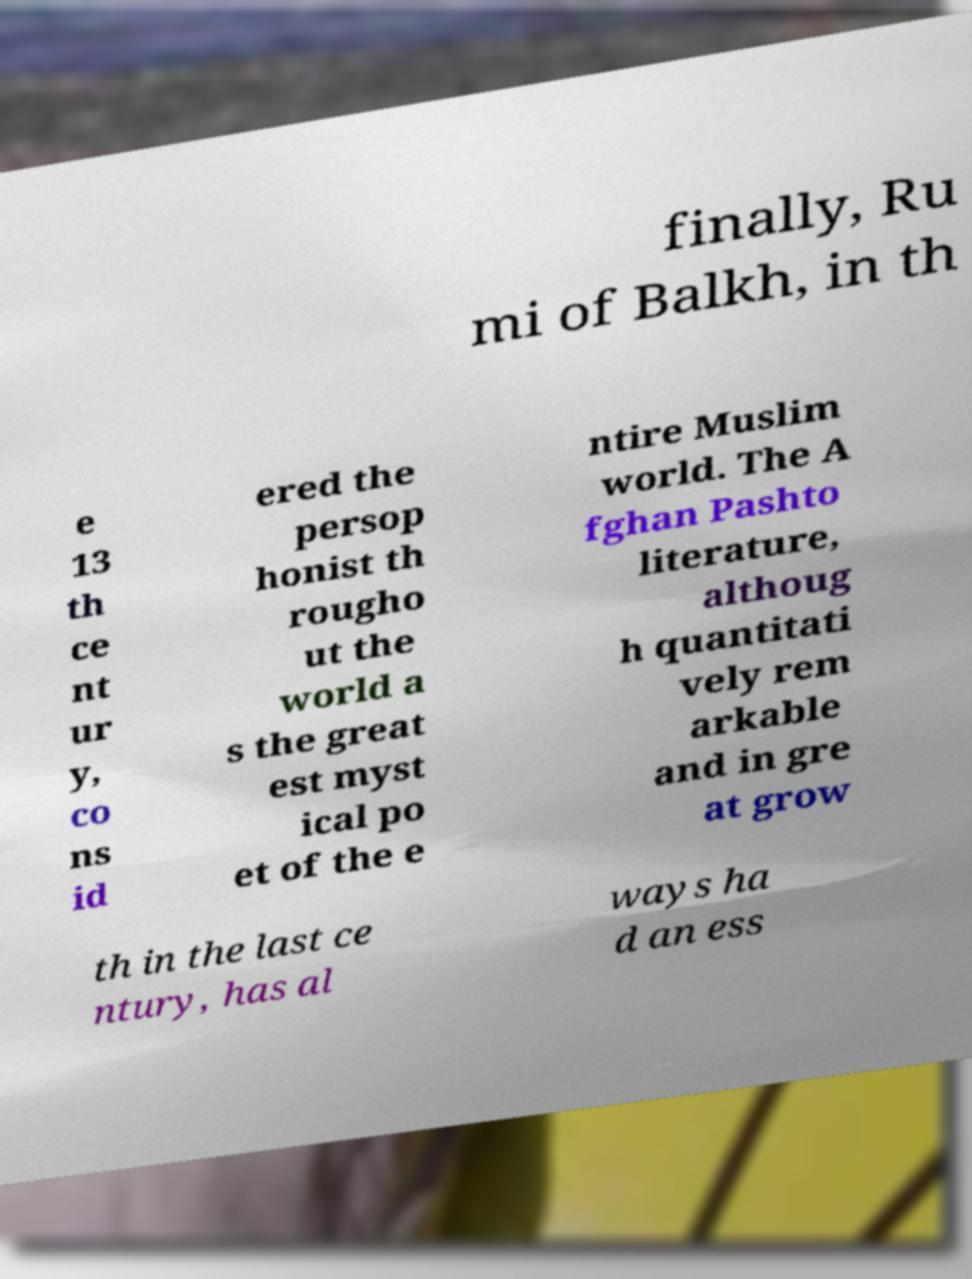Can you read and provide the text displayed in the image?This photo seems to have some interesting text. Can you extract and type it out for me? finally, Ru mi of Balkh, in th e 13 th ce nt ur y, co ns id ered the persop honist th rougho ut the world a s the great est myst ical po et of the e ntire Muslim world. The A fghan Pashto literature, althoug h quantitati vely rem arkable and in gre at grow th in the last ce ntury, has al ways ha d an ess 